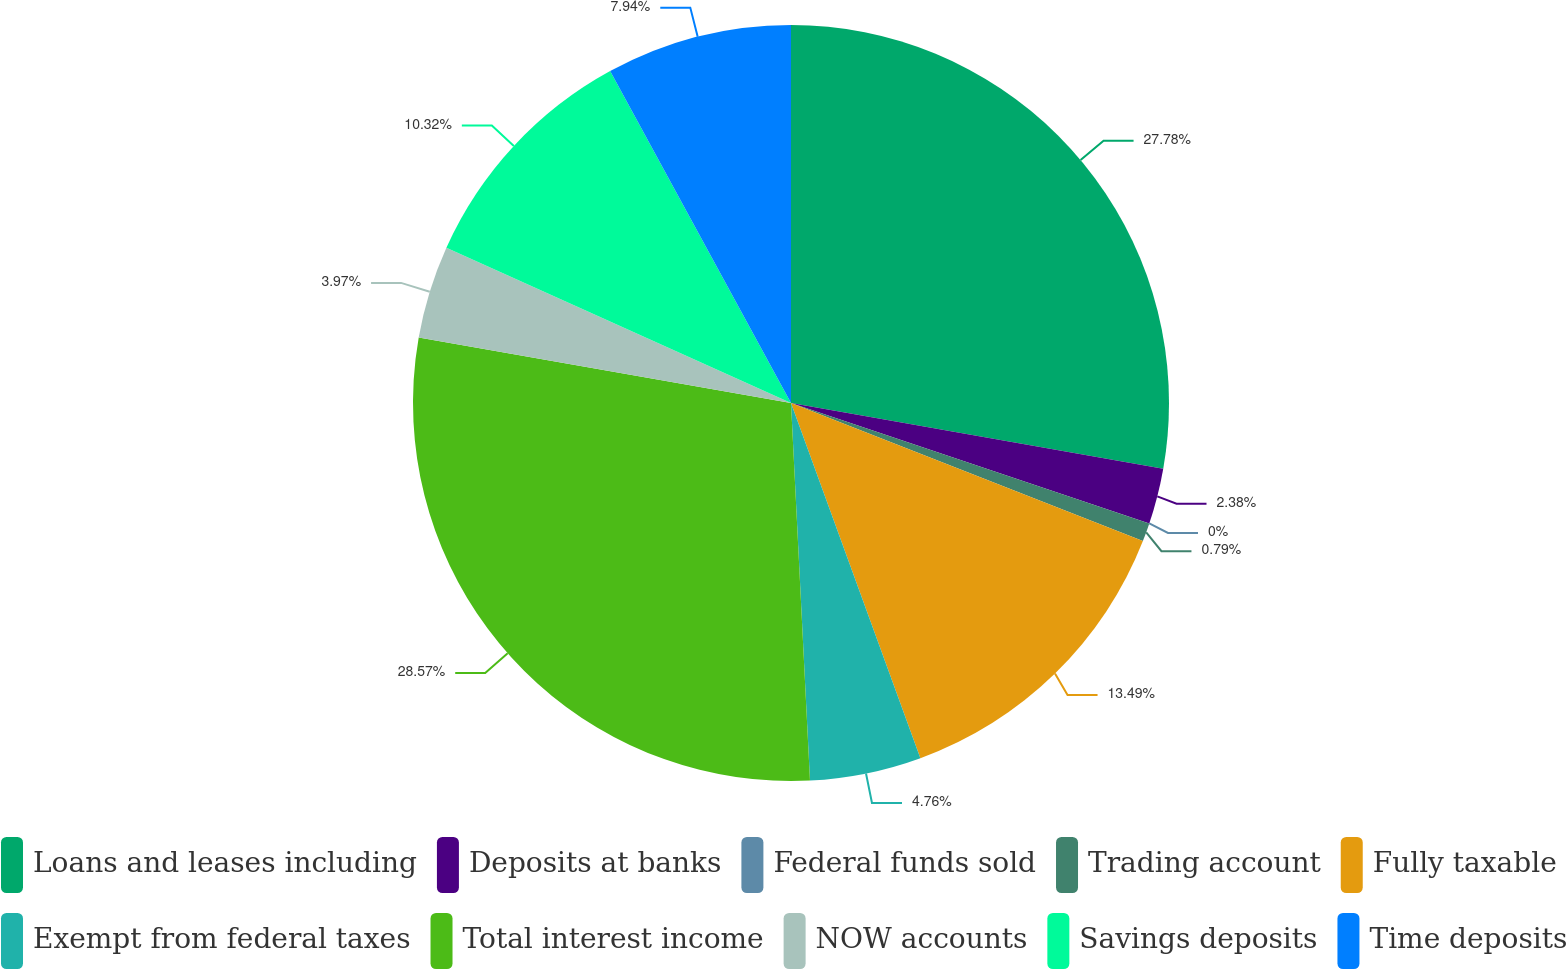Convert chart. <chart><loc_0><loc_0><loc_500><loc_500><pie_chart><fcel>Loans and leases including<fcel>Deposits at banks<fcel>Federal funds sold<fcel>Trading account<fcel>Fully taxable<fcel>Exempt from federal taxes<fcel>Total interest income<fcel>NOW accounts<fcel>Savings deposits<fcel>Time deposits<nl><fcel>27.78%<fcel>2.38%<fcel>0.0%<fcel>0.79%<fcel>13.49%<fcel>4.76%<fcel>28.57%<fcel>3.97%<fcel>10.32%<fcel>7.94%<nl></chart> 